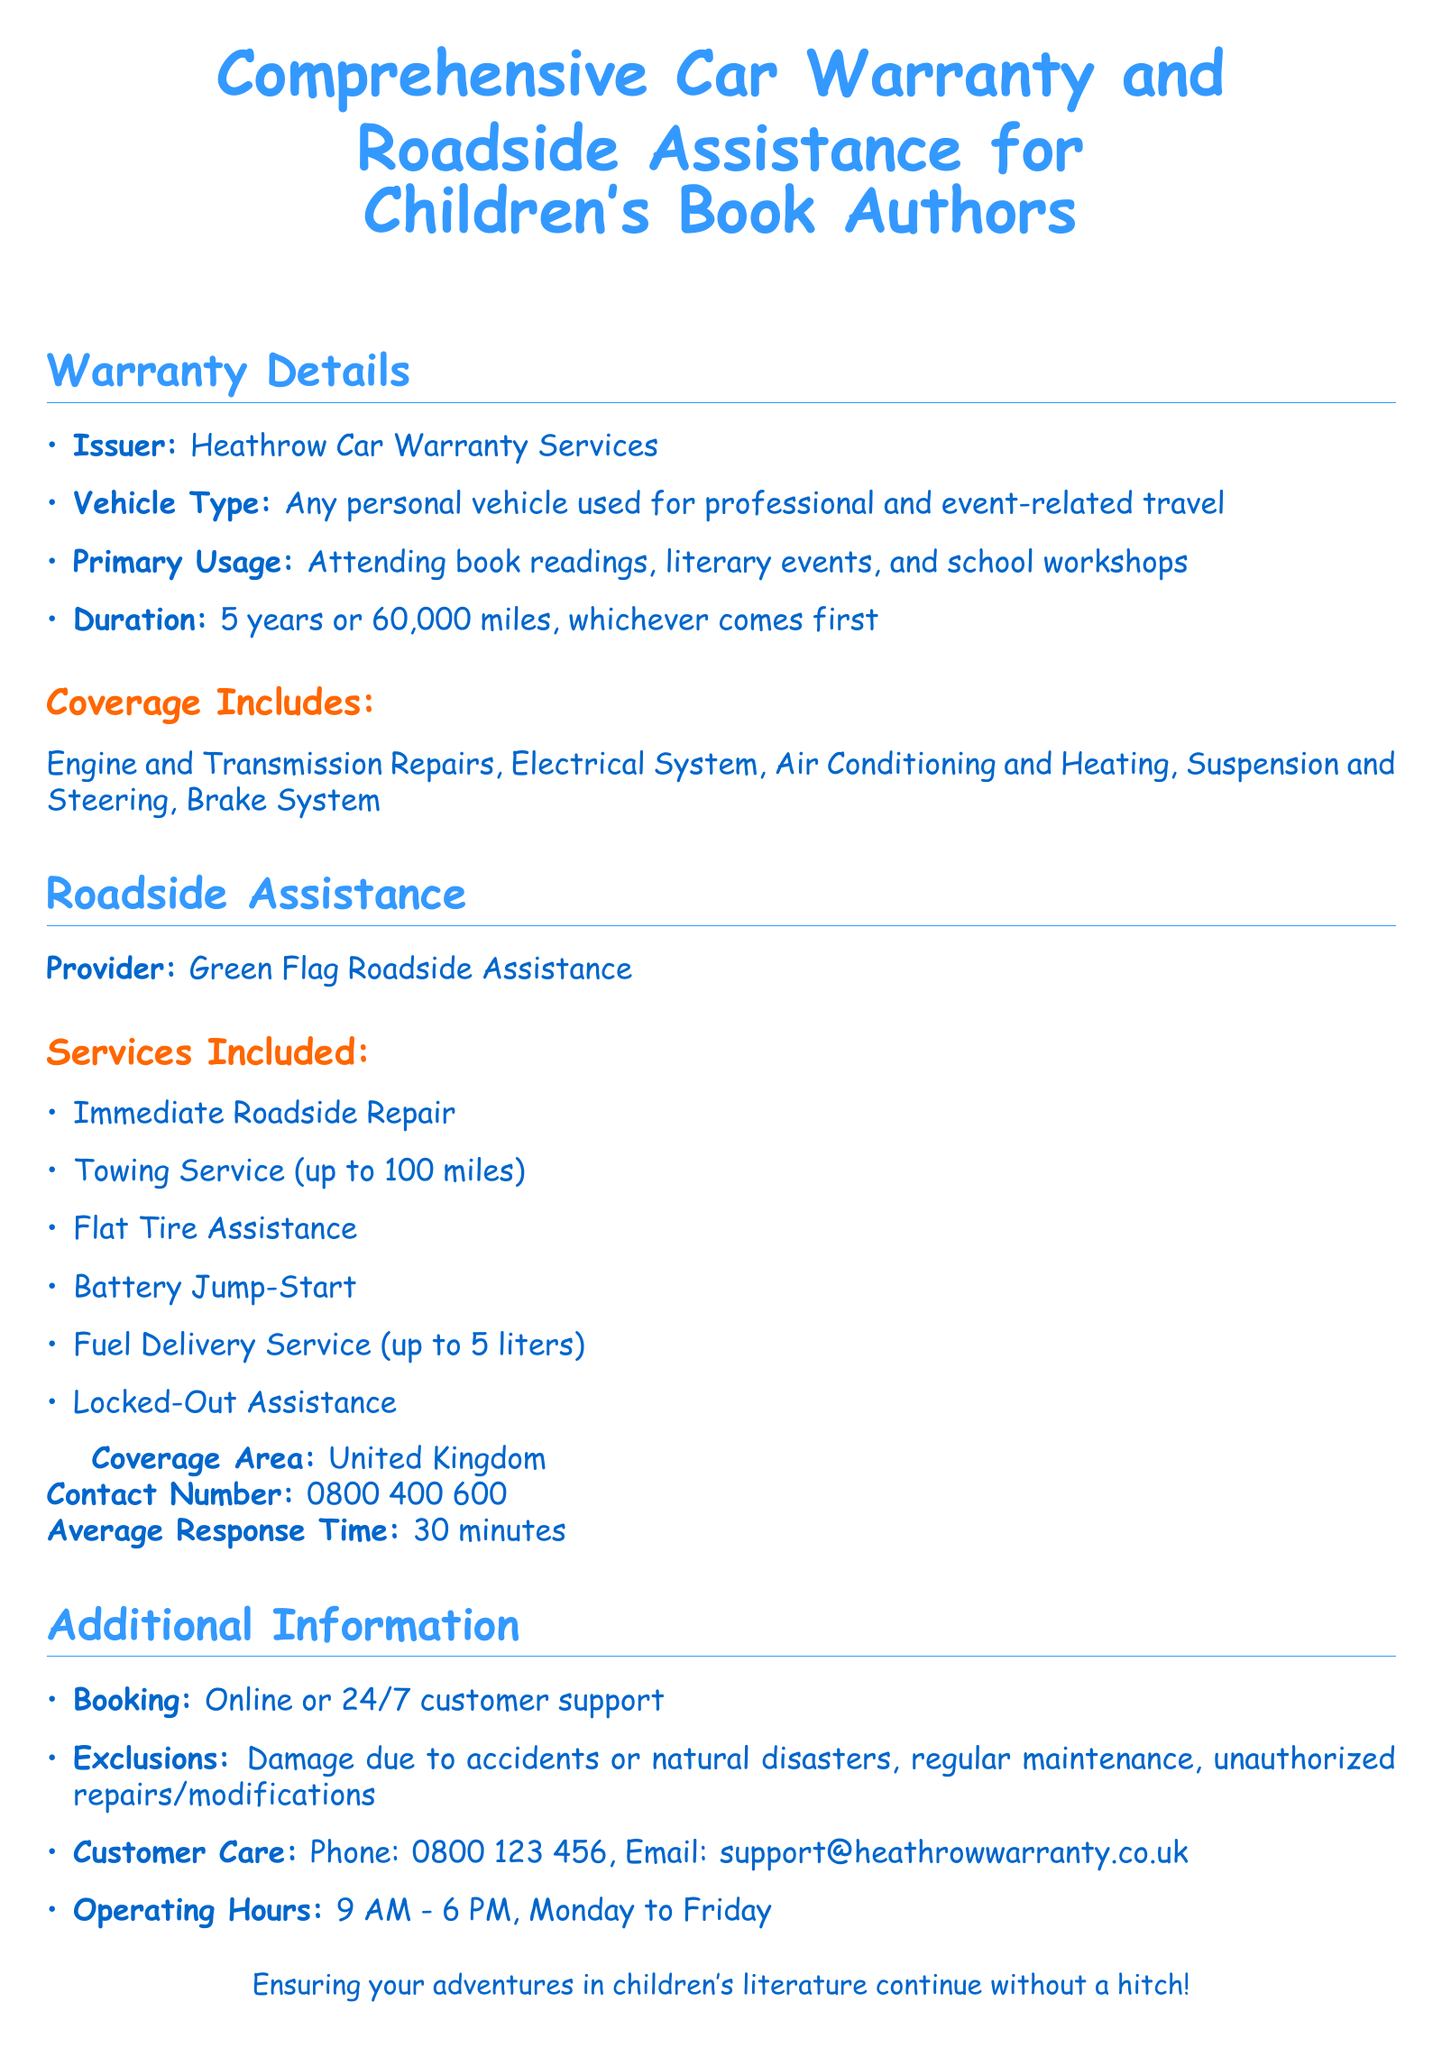What is the issuer of the warranty? The issuer of the warranty is mentioned at the start of the warranty details.
Answer: Heathrow Car Warranty Services What is the primary usage of the vehicle covered? The primary usage describes the reason for which the vehicle is used, specifically for various literary events.
Answer: Attending book readings, literary events, and school workshops What is the duration of the warranty? The duration includes the maximum time and mileage the warranty lasts.
Answer: 5 years or 60,000 miles What type of roadside assistance service is offered for locked-out situations? The document specifies the services included under roadside assistance, which addresses being locked out of the vehicle.
Answer: Locked-Out Assistance What is the average response time for roadside assistance? The response time is provided to give an idea of how quickly help can be expected.
Answer: 30 minutes Which provider offers roadside assistance? The document explicitly states the name of the provider for roadside assistance.
Answer: Green Flag Roadside Assistance What type of vehicles does this warranty cover? The document outlines the specific type of vehicle that is eligible for warranty coverage.
Answer: Any personal vehicle used for professional and event-related travel How many liters of fuel delivery service are covered? The warranty includes details about fuel delivery, specifying the limit on the amount provided.
Answer: Up to 5 liters 